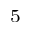Convert formula to latex. <formula><loc_0><loc_0><loc_500><loc_500>^ { 5 }</formula> 